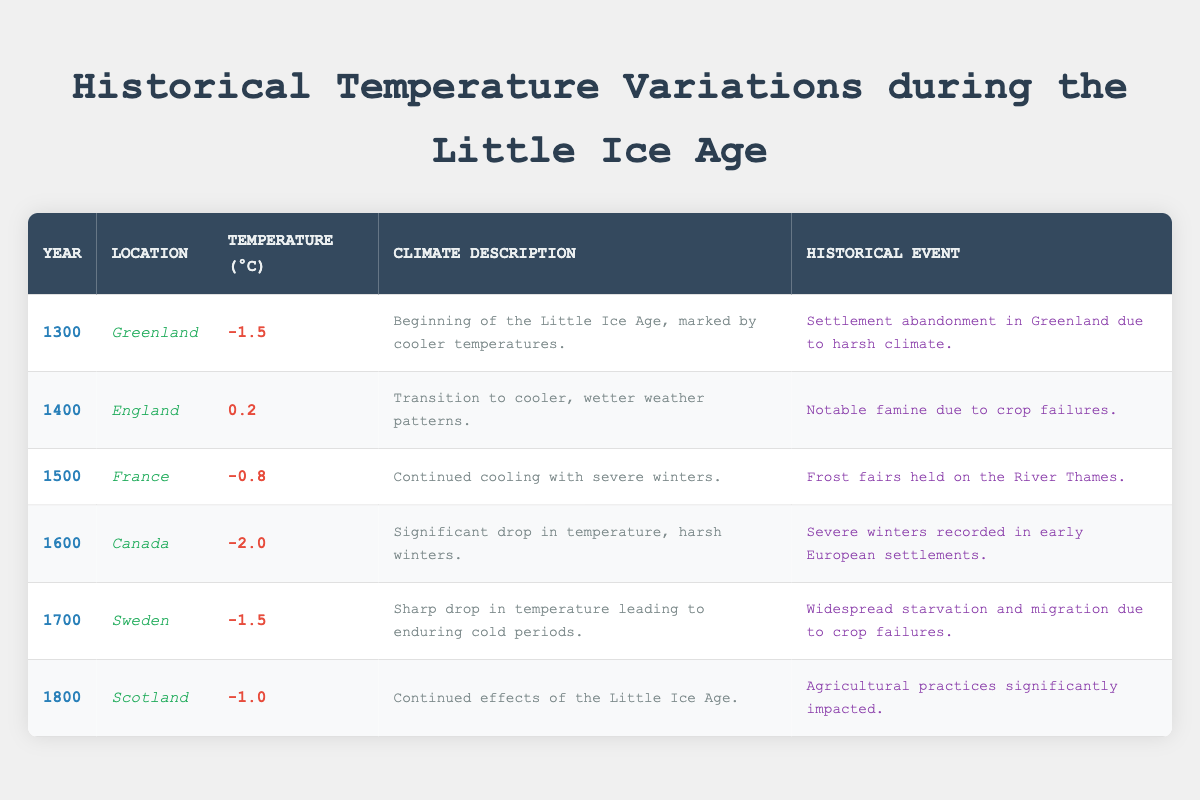What was the temperature recorded in Canada in the year 1600? According to the table, the entry for Canada in the year 1600 shows a temperature of -2.0 degrees Celsius.
Answer: -2.0 Which year had the highest recorded temperature among the listed locations? The listed temperatures from each location are as follows: Greenland -1.5, England 0.2, France -0.8, Canada -2.0, Sweden -1.5, Scotland -1.0. The highest temperature is 0.2 degrees Celsius in England in the year 1400.
Answer: 1400 Is it true that all temperatures recorded during the Little Ice Age were negative? The temperatures recorded are as follows: Greenland -1.5, England 0.2 (positive), France -0.8, Canada -2.0, Sweden -1.5, Scotland -1.0. Since England has a positive temperature, the statement is false.
Answer: False What was the average temperature across all the years listed in the table? To find the average temperature, add all the recorded temperatures: -1.5 + 0.2 - 0.8 - 2.0 - 1.5 - 1.0 = -6.6 degrees Celsius. There are 6 entries, so we divide -6.6 by 6 to get -1.1 degrees Celsius as the average.
Answer: -1.1 Which historical event corresponds with the temperature of -0.8 degrees in France? The entry for France in the year 1500 lists a historical event that is "Frost fairs held on the River Thames," which corresponds with the temperature of -0.8 degrees Celsius.
Answer: Frost fairs held on the River Thames What is the temperature difference between the years 1400 and 1600? The temperature in 1400 is 0.2 degrees Celsius and in 1600 it is -2.0 degrees Celsius. The difference is calculated as follows: 0.2 - (-2.0) = 0.2 + 2.0 = 2.2 degrees.
Answer: 2.2 Did the year 1700 experience the same temperature as the year 1300? The temperature recorded in 1700 is -1.5 degrees Celsius and in 1300 it is also -1.5 degrees Celsius, making the temperatures the same.
Answer: Yes Which location experienced the lowest temperature recorded in this table, and what was that temperature? The location with the lowest temperature is Canada in the year 1600, with a recorded temperature of -2.0 degrees Celsius.
Answer: Canada, -2.0 What pattern can be observed regarding historical events and temperatures from 1300 to 1800? By reviewing the data, a pattern emerges where lower temperatures often correspond with significant adverse events such as settlement abandonment, famine, and starvation in multiple locations. This suggests climate impacts on human activities.
Answer: Adverse events correlate with lower temperatures 